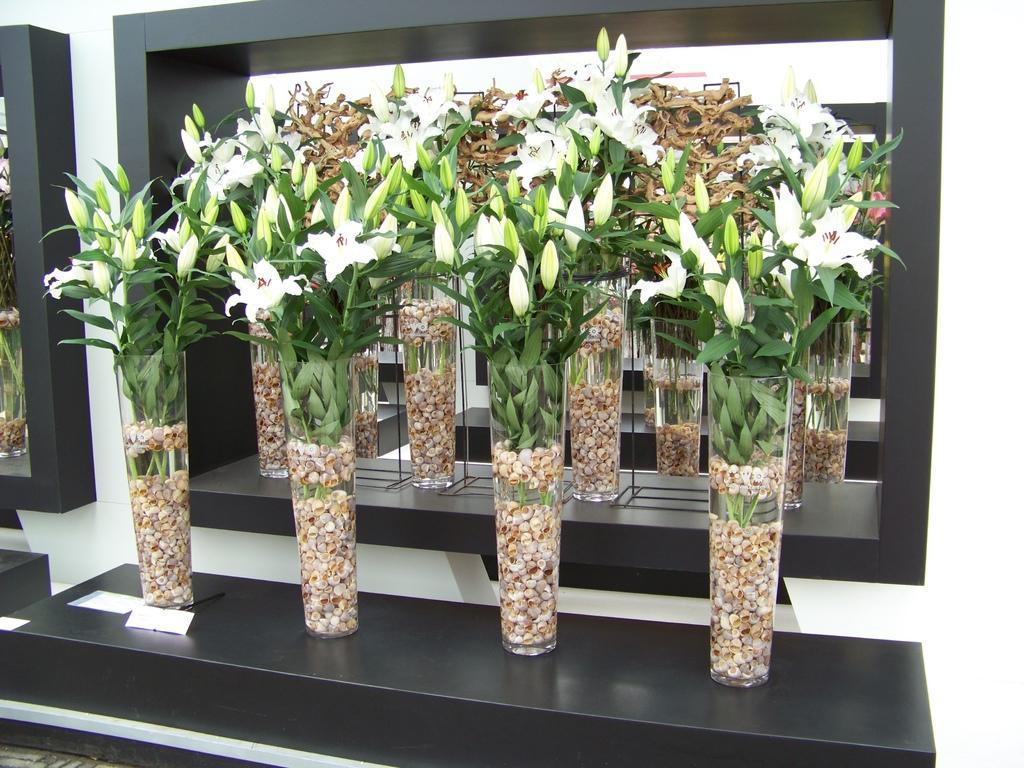How would you summarize this image in a sentence or two? In this image we can see some flower vases which are arranged in shelves and there are some flowers grown to it which are in white color and we can see a wall. 